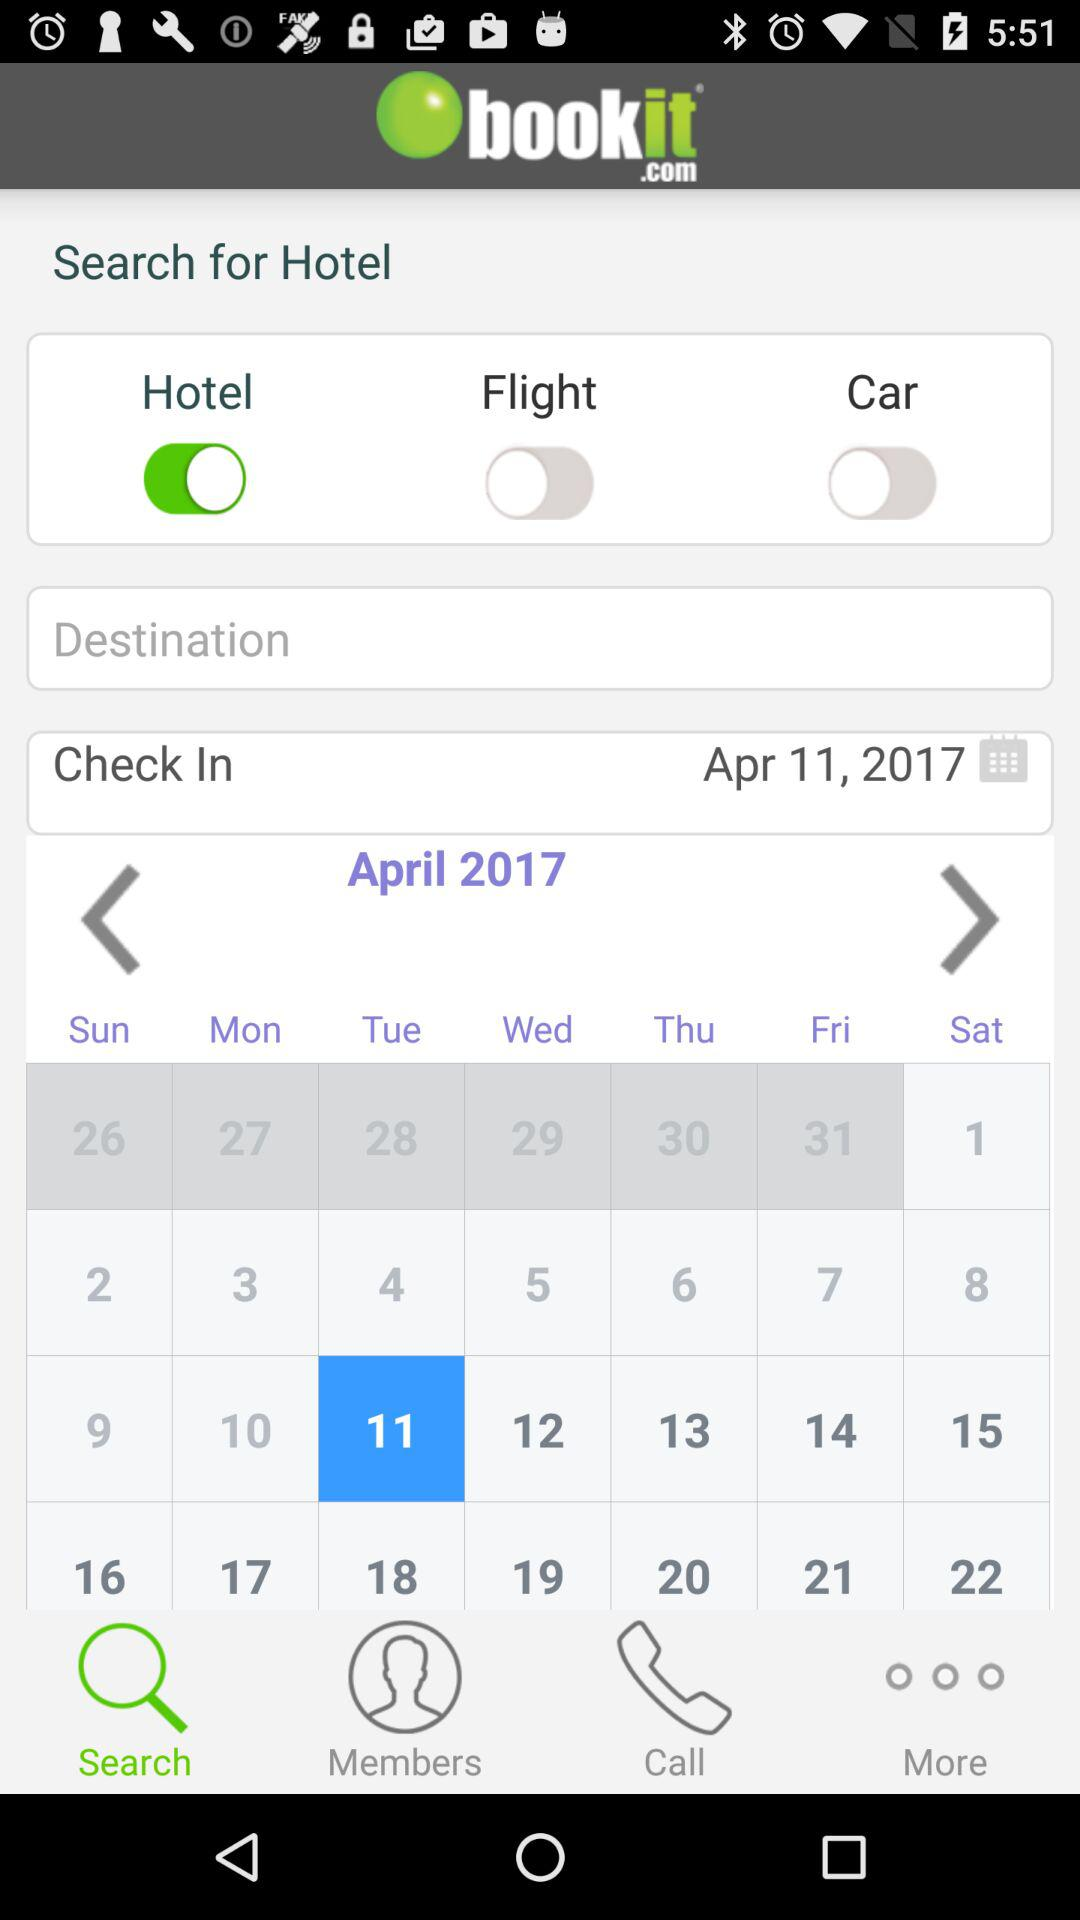What is the app name? The app name is "BookIt.com". 